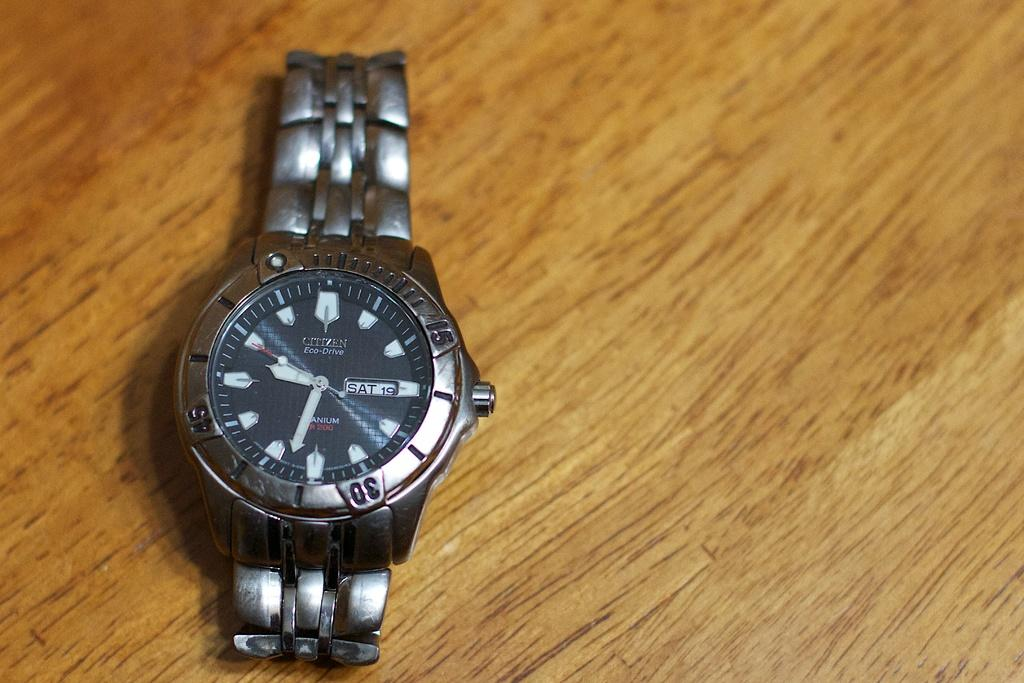<image>
Render a clear and concise summary of the photo. A watch has "Eco-Drive" printed on the face. 